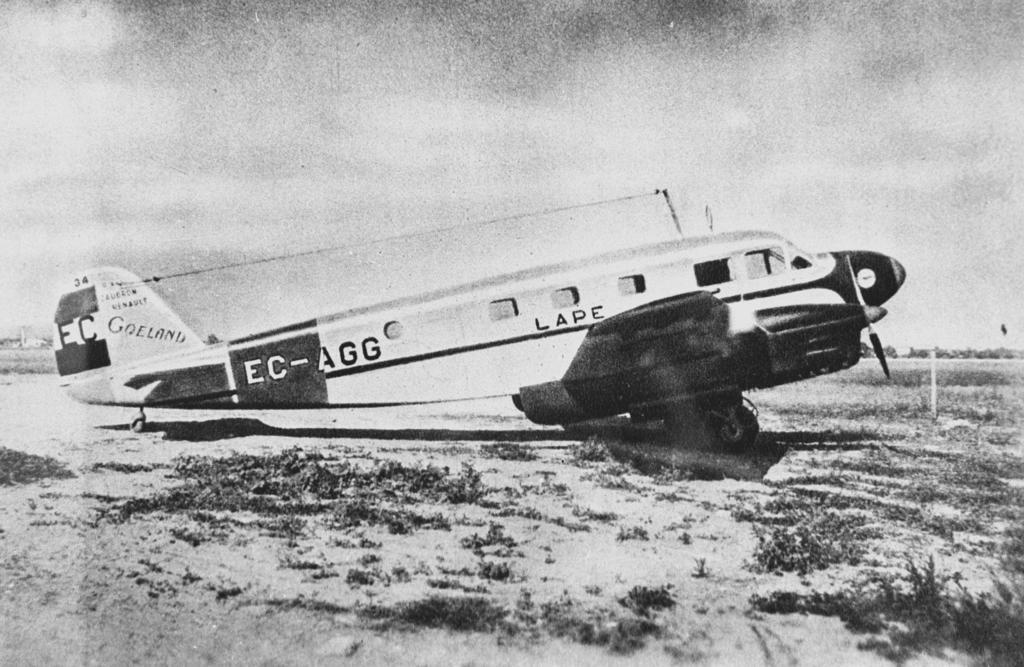Provide a one-sentence caption for the provided image. The EC-AGG Goeland water airplane taking off from the water. 